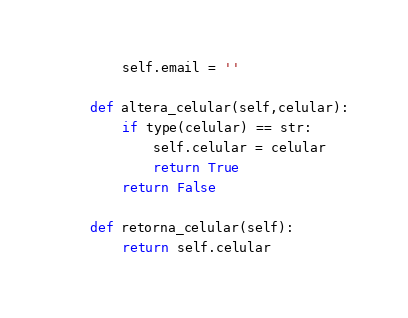<code> <loc_0><loc_0><loc_500><loc_500><_Python_>        self.email = ''
        
    def altera_celular(self,celular):
        if type(celular) == str:
            self.celular = celular
            return True 
        return False 
    
    def retorna_celular(self):
        return self.celular</code> 